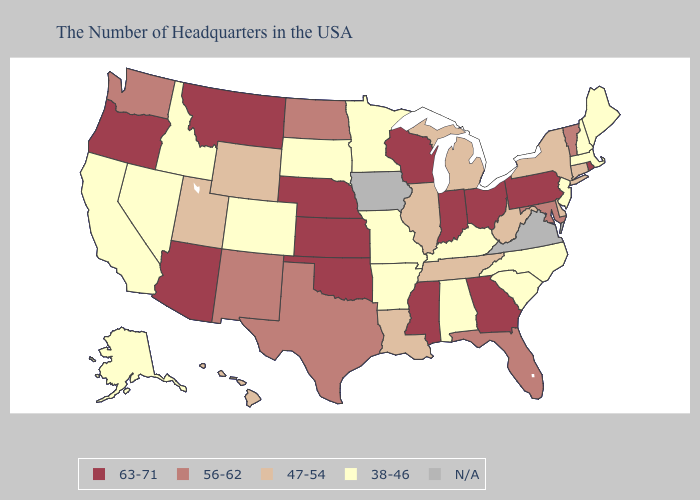What is the lowest value in states that border Louisiana?
Quick response, please. 38-46. Among the states that border Arizona , does California have the lowest value?
Quick response, please. Yes. Which states hav the highest value in the Northeast?
Write a very short answer. Rhode Island, Pennsylvania. Which states have the lowest value in the South?
Answer briefly. North Carolina, South Carolina, Kentucky, Alabama, Arkansas. Among the states that border Louisiana , which have the highest value?
Quick response, please. Mississippi. What is the value of Oregon?
Short answer required. 63-71. Among the states that border Virginia , which have the lowest value?
Keep it brief. North Carolina, Kentucky. Name the states that have a value in the range N/A?
Keep it brief. Virginia, Iowa. What is the value of Arkansas?
Quick response, please. 38-46. What is the lowest value in the USA?
Short answer required. 38-46. Name the states that have a value in the range 38-46?
Give a very brief answer. Maine, Massachusetts, New Hampshire, New Jersey, North Carolina, South Carolina, Kentucky, Alabama, Missouri, Arkansas, Minnesota, South Dakota, Colorado, Idaho, Nevada, California, Alaska. How many symbols are there in the legend?
Give a very brief answer. 5. What is the value of Florida?
Concise answer only. 56-62. Among the states that border Idaho , does Wyoming have the lowest value?
Answer briefly. No. Which states have the highest value in the USA?
Concise answer only. Rhode Island, Pennsylvania, Ohio, Georgia, Indiana, Wisconsin, Mississippi, Kansas, Nebraska, Oklahoma, Montana, Arizona, Oregon. 